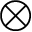Convert formula to latex. <formula><loc_0><loc_0><loc_500><loc_500>\otimes</formula> 